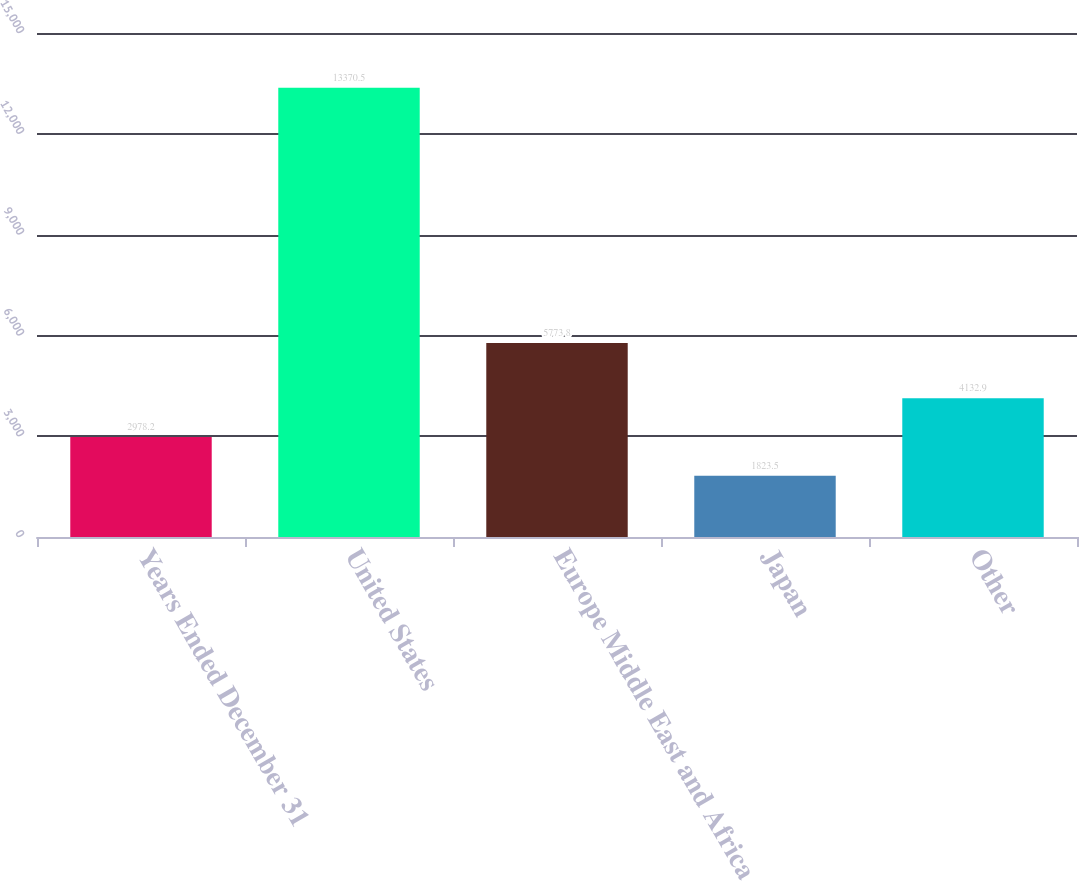Convert chart. <chart><loc_0><loc_0><loc_500><loc_500><bar_chart><fcel>Years Ended December 31<fcel>United States<fcel>Europe Middle East and Africa<fcel>Japan<fcel>Other<nl><fcel>2978.2<fcel>13370.5<fcel>5773.8<fcel>1823.5<fcel>4132.9<nl></chart> 